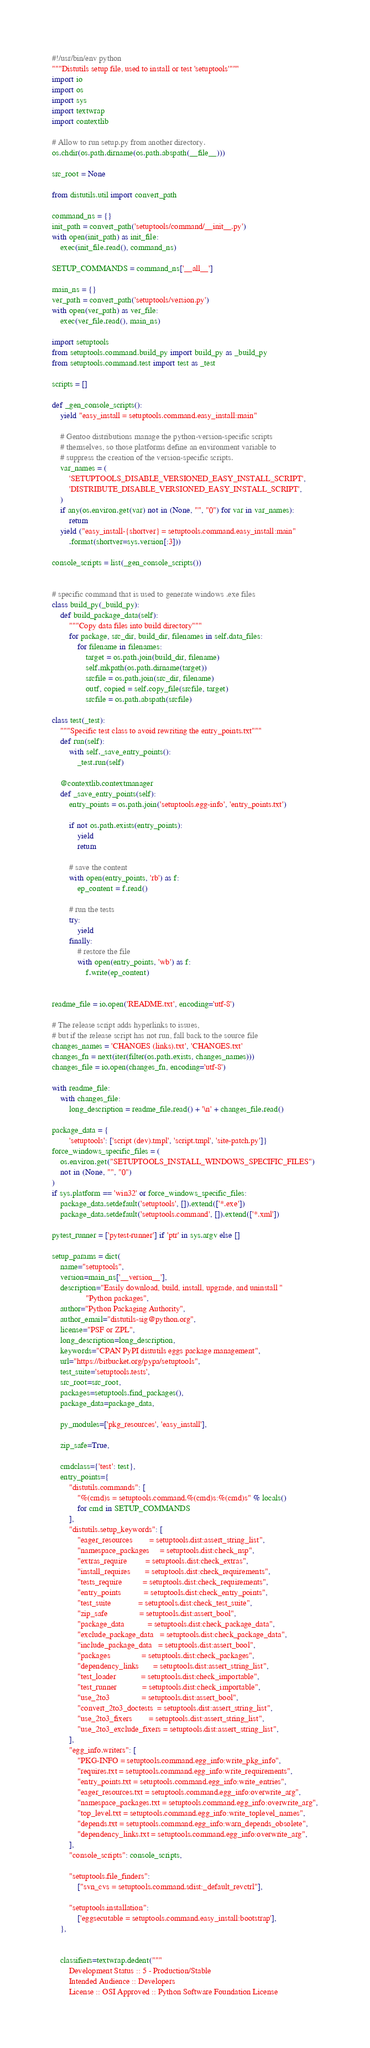<code> <loc_0><loc_0><loc_500><loc_500><_Python_>#!/usr/bin/env python
"""Distutils setup file, used to install or test 'setuptools'"""
import io
import os
import sys
import textwrap
import contextlib

# Allow to run setup.py from another directory.
os.chdir(os.path.dirname(os.path.abspath(__file__)))

src_root = None

from distutils.util import convert_path

command_ns = {}
init_path = convert_path('setuptools/command/__init__.py')
with open(init_path) as init_file:
    exec(init_file.read(), command_ns)

SETUP_COMMANDS = command_ns['__all__']

main_ns = {}
ver_path = convert_path('setuptools/version.py')
with open(ver_path) as ver_file:
    exec(ver_file.read(), main_ns)

import setuptools
from setuptools.command.build_py import build_py as _build_py
from setuptools.command.test import test as _test

scripts = []

def _gen_console_scripts():
    yield "easy_install = setuptools.command.easy_install:main"

    # Gentoo distributions manage the python-version-specific scripts
    # themselves, so those platforms define an environment variable to
    # suppress the creation of the version-specific scripts.
    var_names = (
        'SETUPTOOLS_DISABLE_VERSIONED_EASY_INSTALL_SCRIPT',
        'DISTRIBUTE_DISABLE_VERSIONED_EASY_INSTALL_SCRIPT',
    )
    if any(os.environ.get(var) not in (None, "", "0") for var in var_names):
        return
    yield ("easy_install-{shortver} = setuptools.command.easy_install:main"
        .format(shortver=sys.version[:3]))

console_scripts = list(_gen_console_scripts())


# specific command that is used to generate windows .exe files
class build_py(_build_py):
    def build_package_data(self):
        """Copy data files into build directory"""
        for package, src_dir, build_dir, filenames in self.data_files:
            for filename in filenames:
                target = os.path.join(build_dir, filename)
                self.mkpath(os.path.dirname(target))
                srcfile = os.path.join(src_dir, filename)
                outf, copied = self.copy_file(srcfile, target)
                srcfile = os.path.abspath(srcfile)

class test(_test):
    """Specific test class to avoid rewriting the entry_points.txt"""
    def run(self):
        with self._save_entry_points():
            _test.run(self)

    @contextlib.contextmanager
    def _save_entry_points(self):
        entry_points = os.path.join('setuptools.egg-info', 'entry_points.txt')

        if not os.path.exists(entry_points):
            yield
            return

        # save the content
        with open(entry_points, 'rb') as f:
            ep_content = f.read()

        # run the tests
        try:
            yield
        finally:
            # restore the file
            with open(entry_points, 'wb') as f:
                f.write(ep_content)


readme_file = io.open('README.txt', encoding='utf-8')

# The release script adds hyperlinks to issues,
# but if the release script has not run, fall back to the source file
changes_names = 'CHANGES (links).txt', 'CHANGES.txt'
changes_fn = next(iter(filter(os.path.exists, changes_names)))
changes_file = io.open(changes_fn, encoding='utf-8')

with readme_file:
    with changes_file:
        long_description = readme_file.read() + '\n' + changes_file.read()

package_data = {
        'setuptools': ['script (dev).tmpl', 'script.tmpl', 'site-patch.py']}
force_windows_specific_files = (
    os.environ.get("SETUPTOOLS_INSTALL_WINDOWS_SPECIFIC_FILES")
    not in (None, "", "0")
)
if sys.platform == 'win32' or force_windows_specific_files:
    package_data.setdefault('setuptools', []).extend(['*.exe'])
    package_data.setdefault('setuptools.command', []).extend(['*.xml'])

pytest_runner = ['pytest-runner'] if 'ptr' in sys.argv else []

setup_params = dict(
    name="setuptools",
    version=main_ns['__version__'],
    description="Easily download, build, install, upgrade, and uninstall "
                "Python packages",
    author="Python Packaging Authority",
    author_email="distutils-sig@python.org",
    license="PSF or ZPL",
    long_description=long_description,
    keywords="CPAN PyPI distutils eggs package management",
    url="https://bitbucket.org/pypa/setuptools",
    test_suite='setuptools.tests',
    src_root=src_root,
    packages=setuptools.find_packages(),
    package_data=package_data,

    py_modules=['pkg_resources', 'easy_install'],

    zip_safe=True,

    cmdclass={'test': test},
    entry_points={
        "distutils.commands": [
            "%(cmd)s = setuptools.command.%(cmd)s:%(cmd)s" % locals()
            for cmd in SETUP_COMMANDS
        ],
        "distutils.setup_keywords": [
            "eager_resources        = setuptools.dist:assert_string_list",
            "namespace_packages     = setuptools.dist:check_nsp",
            "extras_require         = setuptools.dist:check_extras",
            "install_requires       = setuptools.dist:check_requirements",
            "tests_require          = setuptools.dist:check_requirements",
            "entry_points           = setuptools.dist:check_entry_points",
            "test_suite             = setuptools.dist:check_test_suite",
            "zip_safe               = setuptools.dist:assert_bool",
            "package_data           = setuptools.dist:check_package_data",
            "exclude_package_data   = setuptools.dist:check_package_data",
            "include_package_data   = setuptools.dist:assert_bool",
            "packages               = setuptools.dist:check_packages",
            "dependency_links       = setuptools.dist:assert_string_list",
            "test_loader            = setuptools.dist:check_importable",
            "test_runner            = setuptools.dist:check_importable",
            "use_2to3               = setuptools.dist:assert_bool",
            "convert_2to3_doctests  = setuptools.dist:assert_string_list",
            "use_2to3_fixers        = setuptools.dist:assert_string_list",
            "use_2to3_exclude_fixers = setuptools.dist:assert_string_list",
        ],
        "egg_info.writers": [
            "PKG-INFO = setuptools.command.egg_info:write_pkg_info",
            "requires.txt = setuptools.command.egg_info:write_requirements",
            "entry_points.txt = setuptools.command.egg_info:write_entries",
            "eager_resources.txt = setuptools.command.egg_info:overwrite_arg",
            "namespace_packages.txt = setuptools.command.egg_info:overwrite_arg",
            "top_level.txt = setuptools.command.egg_info:write_toplevel_names",
            "depends.txt = setuptools.command.egg_info:warn_depends_obsolete",
            "dependency_links.txt = setuptools.command.egg_info:overwrite_arg",
        ],
        "console_scripts": console_scripts,

        "setuptools.file_finders":
            ["svn_cvs = setuptools.command.sdist:_default_revctrl"],

        "setuptools.installation":
            ['eggsecutable = setuptools.command.easy_install:bootstrap'],
    },


    classifiers=textwrap.dedent("""
        Development Status :: 5 - Production/Stable
        Intended Audience :: Developers
        License :: OSI Approved :: Python Software Foundation License</code> 